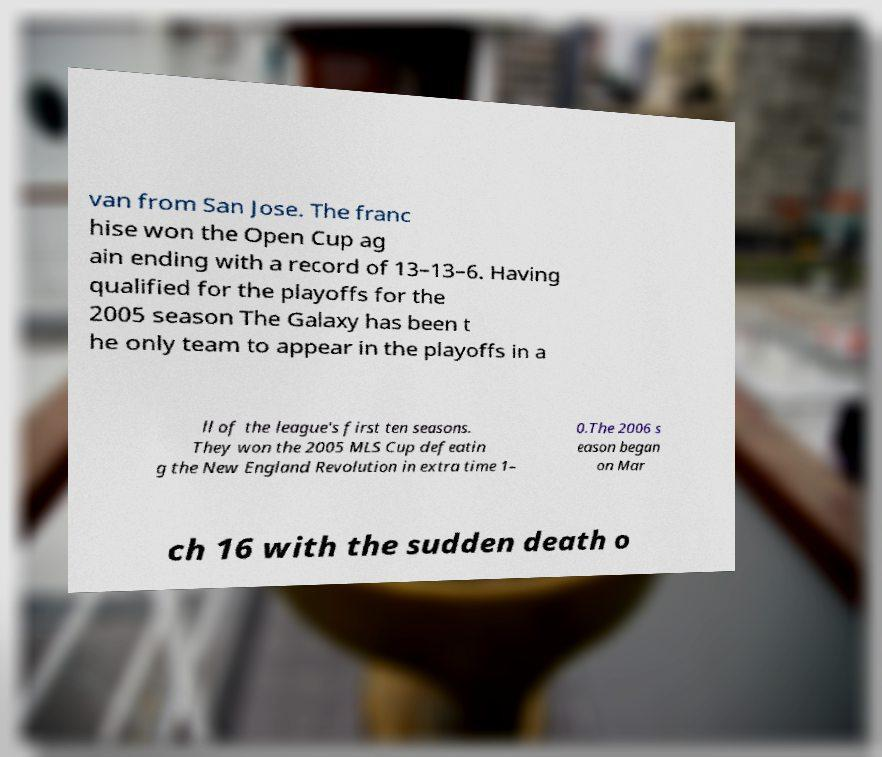Can you accurately transcribe the text from the provided image for me? van from San Jose. The franc hise won the Open Cup ag ain ending with a record of 13–13–6. Having qualified for the playoffs for the 2005 season The Galaxy has been t he only team to appear in the playoffs in a ll of the league's first ten seasons. They won the 2005 MLS Cup defeatin g the New England Revolution in extra time 1– 0.The 2006 s eason began on Mar ch 16 with the sudden death o 